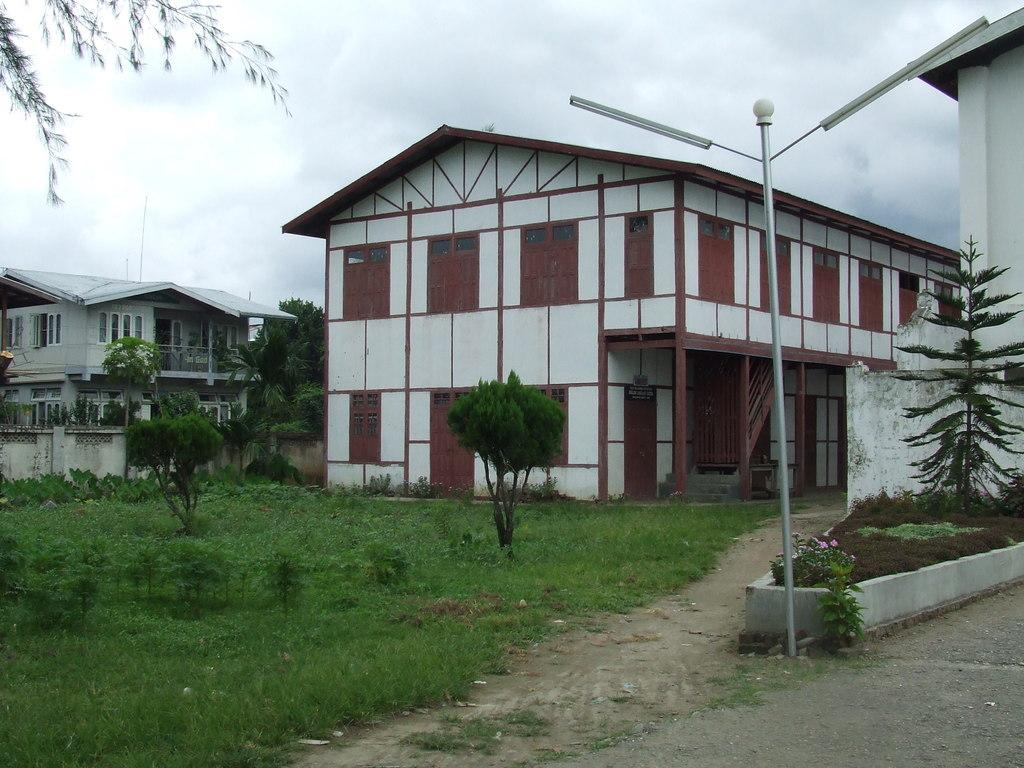What type of structures can be seen in the image? There are buildings in the image. What natural elements are present in the image? There are trees and plants in the image. What man-made objects can be seen in the image? There are poles in the image. What is visible at the bottom of the image? There is ground visible at the bottom of the image. How many rabbits can be seen sleeping on the poles in the image? There are no rabbits present in the image, and they are not sleeping on the poles. What type of knife is being used to cut the plants in the image? There is no knife present in the image, and no plants are being cut. 